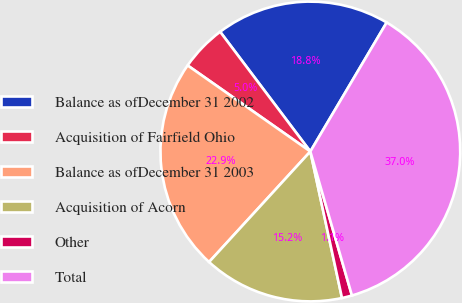Convert chart. <chart><loc_0><loc_0><loc_500><loc_500><pie_chart><fcel>Balance as ofDecember 31 2002<fcel>Acquisition of Fairfield Ohio<fcel>Balance as ofDecember 31 2003<fcel>Acquisition of Acorn<fcel>Other<fcel>Total<nl><fcel>18.78%<fcel>4.99%<fcel>22.93%<fcel>15.19%<fcel>1.09%<fcel>37.02%<nl></chart> 